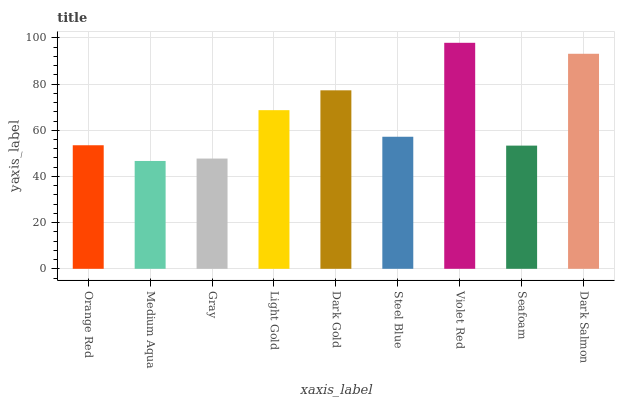Is Medium Aqua the minimum?
Answer yes or no. Yes. Is Violet Red the maximum?
Answer yes or no. Yes. Is Gray the minimum?
Answer yes or no. No. Is Gray the maximum?
Answer yes or no. No. Is Gray greater than Medium Aqua?
Answer yes or no. Yes. Is Medium Aqua less than Gray?
Answer yes or no. Yes. Is Medium Aqua greater than Gray?
Answer yes or no. No. Is Gray less than Medium Aqua?
Answer yes or no. No. Is Steel Blue the high median?
Answer yes or no. Yes. Is Steel Blue the low median?
Answer yes or no. Yes. Is Gray the high median?
Answer yes or no. No. Is Dark Gold the low median?
Answer yes or no. No. 